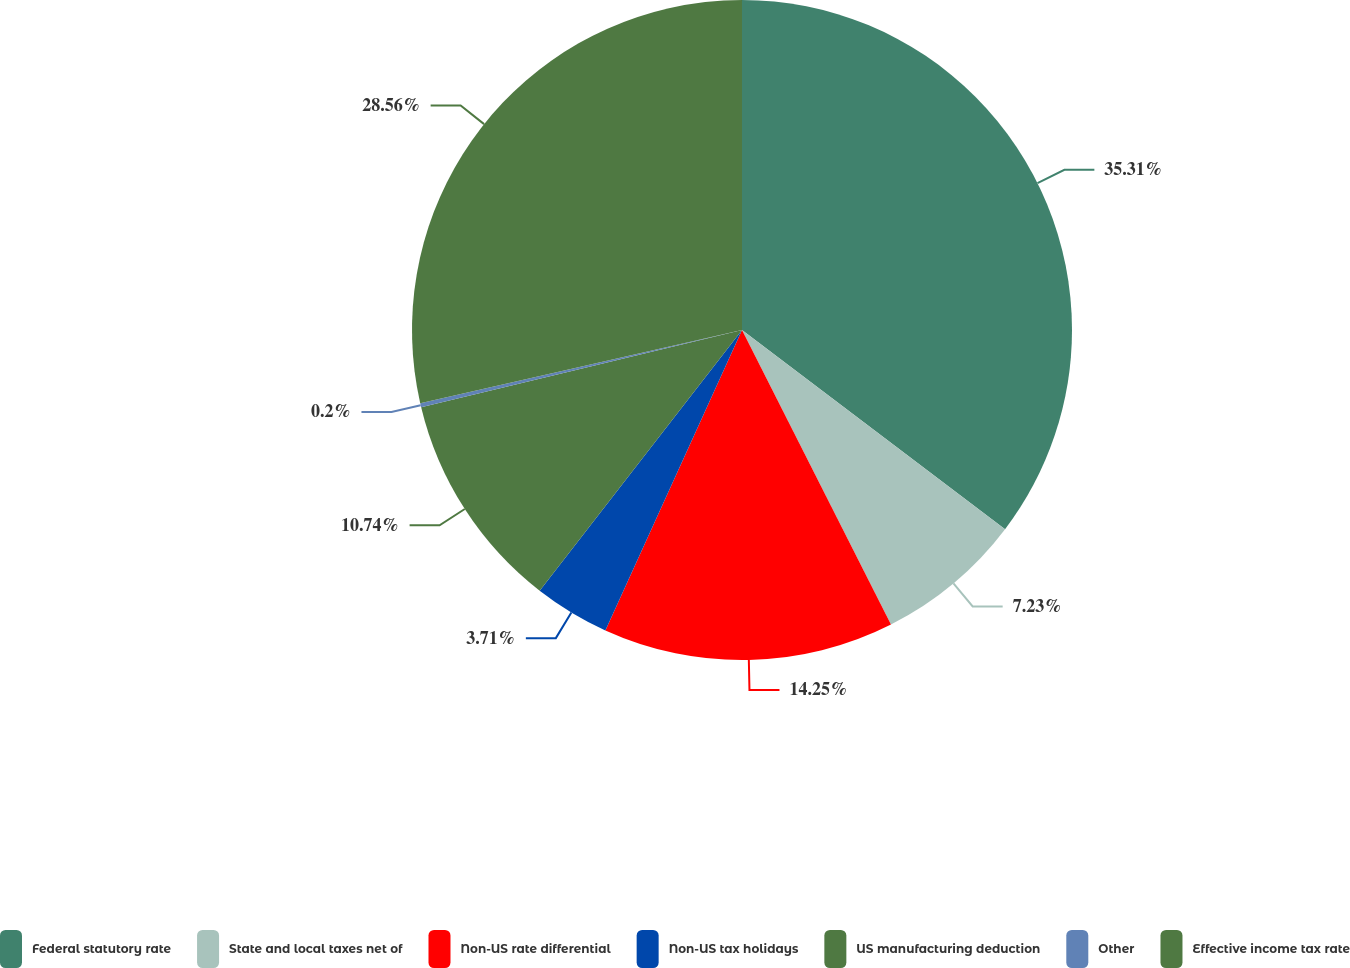Convert chart. <chart><loc_0><loc_0><loc_500><loc_500><pie_chart><fcel>Federal statutory rate<fcel>State and local taxes net of<fcel>Non-US rate differential<fcel>Non-US tax holidays<fcel>US manufacturing deduction<fcel>Other<fcel>Effective income tax rate<nl><fcel>35.32%<fcel>7.23%<fcel>14.25%<fcel>3.71%<fcel>10.74%<fcel>0.2%<fcel>28.56%<nl></chart> 